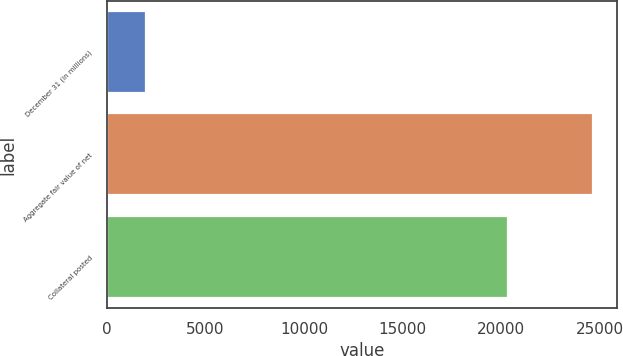Convert chart. <chart><loc_0><loc_0><loc_500><loc_500><bar_chart><fcel>December 31 (in millions)<fcel>Aggregate fair value of net<fcel>Collateral posted<nl><fcel>2013<fcel>24631<fcel>20346<nl></chart> 